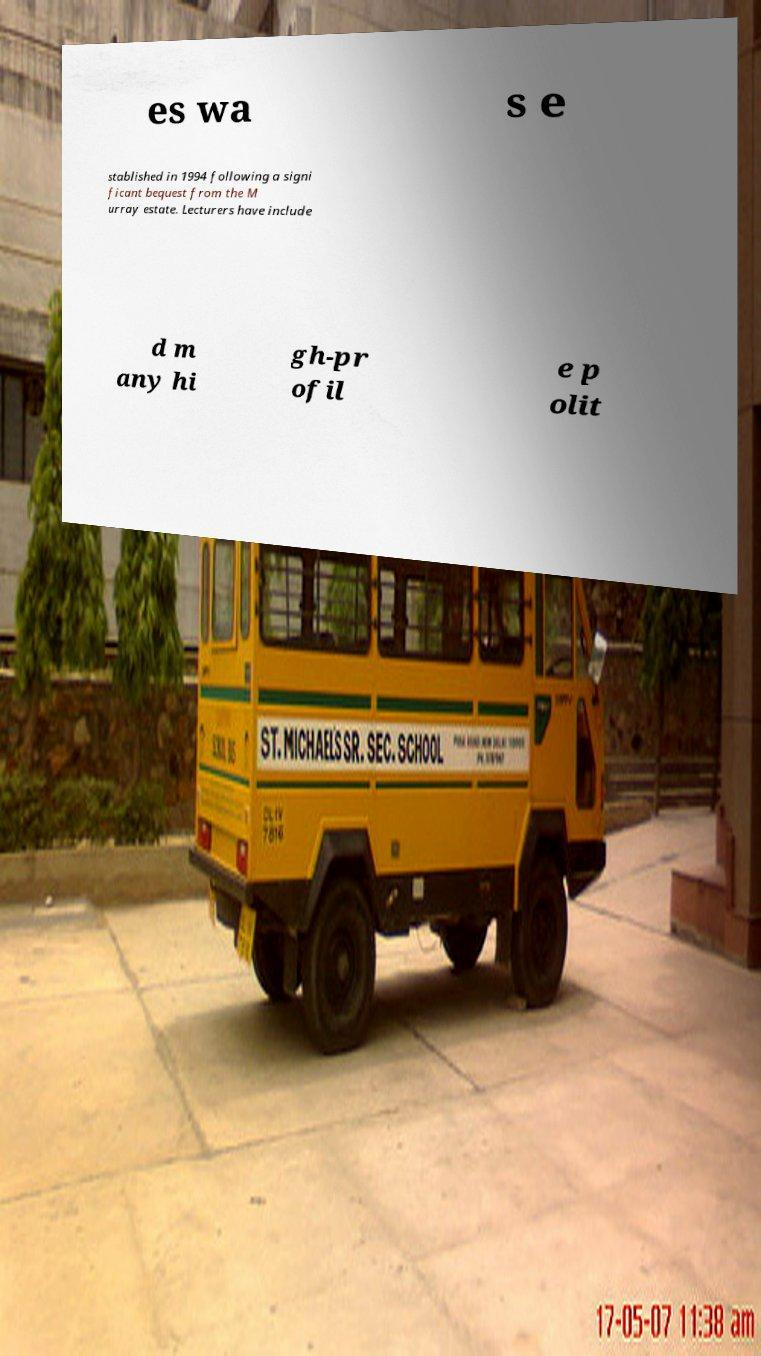Please identify and transcribe the text found in this image. es wa s e stablished in 1994 following a signi ficant bequest from the M urray estate. Lecturers have include d m any hi gh-pr ofil e p olit 